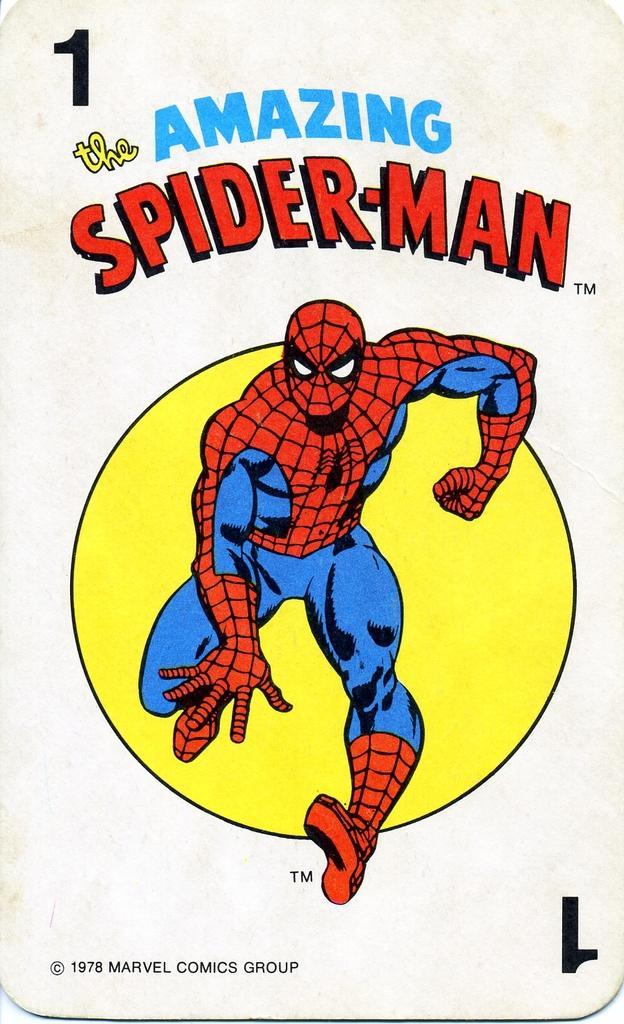How would you summarize this image in a sentence or two? In this image we can see a depiction of spider man, some text and number. 